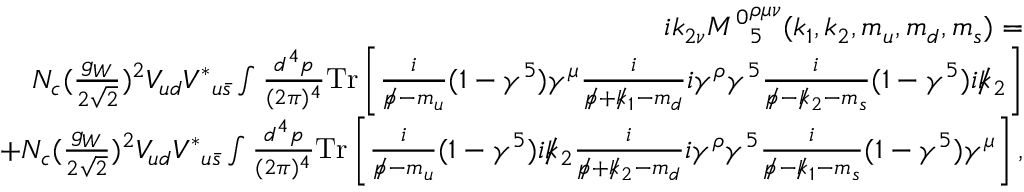Convert formula to latex. <formula><loc_0><loc_0><loc_500><loc_500>\begin{array} { r l r } & { i k _ { 2 \nu } { M ^ { 0 } } _ { 5 } ^ { \rho \mu \nu } ( k _ { 1 } , k _ { 2 } , m _ { u } , m _ { d } , m _ { s } ) = } \\ & { N _ { c } ( \frac { g _ { W } } { 2 \sqrt { 2 } } ) ^ { 2 } V _ { u d } { V ^ { \ast } } _ { u \bar { s } } \int \frac { d ^ { 4 } p } { ( 2 \pi ) ^ { 4 } } { T r } \left [ \frac { i } { p \, / - m _ { u } } ( 1 - \gamma ^ { 5 } ) \gamma ^ { \mu } \frac { i } { p \, / + k \, / _ { 1 } - m _ { d } } i \gamma ^ { \rho } \gamma ^ { 5 } \frac { i } { p \, / - k \, / _ { 2 } - m _ { s } } ( 1 - \gamma ^ { 5 } ) i k \, / _ { 2 } \right ] } \\ & { + N _ { c } ( \frac { g _ { W } } { 2 \sqrt { 2 } } ) ^ { 2 } V _ { u d } { V ^ { \ast } } _ { u \bar { s } } \int \frac { d ^ { 4 } p } { ( 2 \pi ) ^ { 4 } } { T r } \left [ \frac { i } { p \, / - m _ { u } } ( 1 - \gamma ^ { 5 } ) i k \, / _ { 2 } \frac { i } { p \, / + k \, / _ { 2 } - m _ { d } } i \gamma ^ { \rho } \gamma ^ { 5 } \frac { i } { p \, / - k \, / _ { 1 } - m _ { s } } ( 1 - \gamma ^ { 5 } ) \gamma ^ { \mu } \right ] , } \end{array}</formula> 